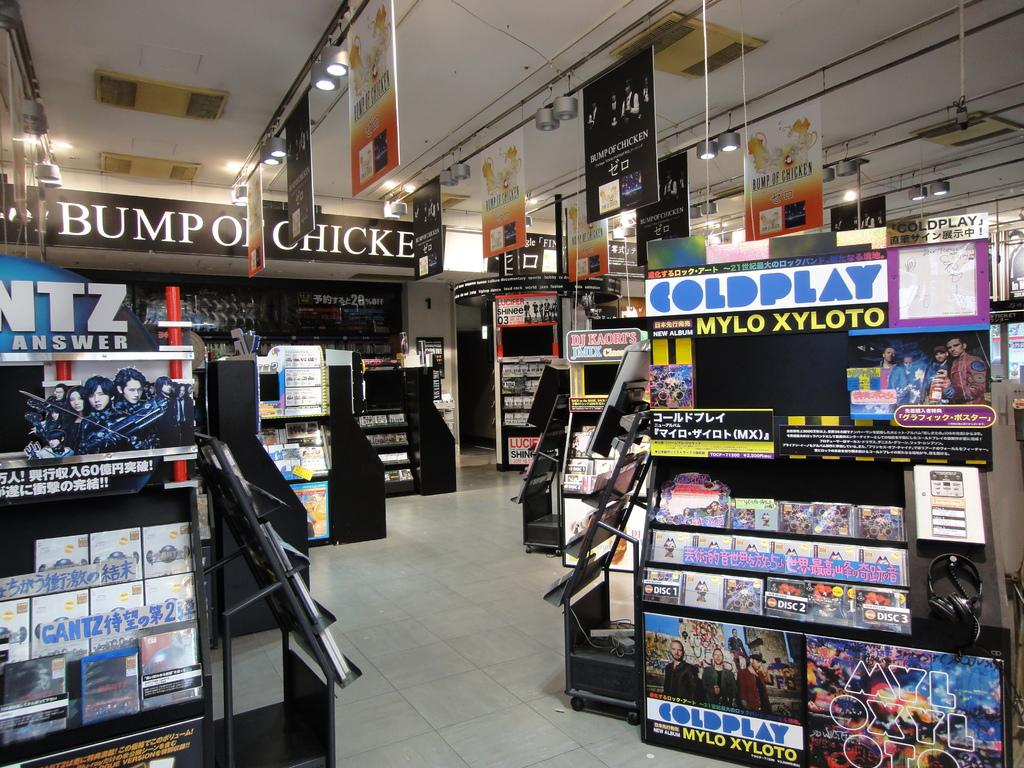<image>
Present a compact description of the photo's key features. Many displays of movies including one that says COLDPLAY on the top. 